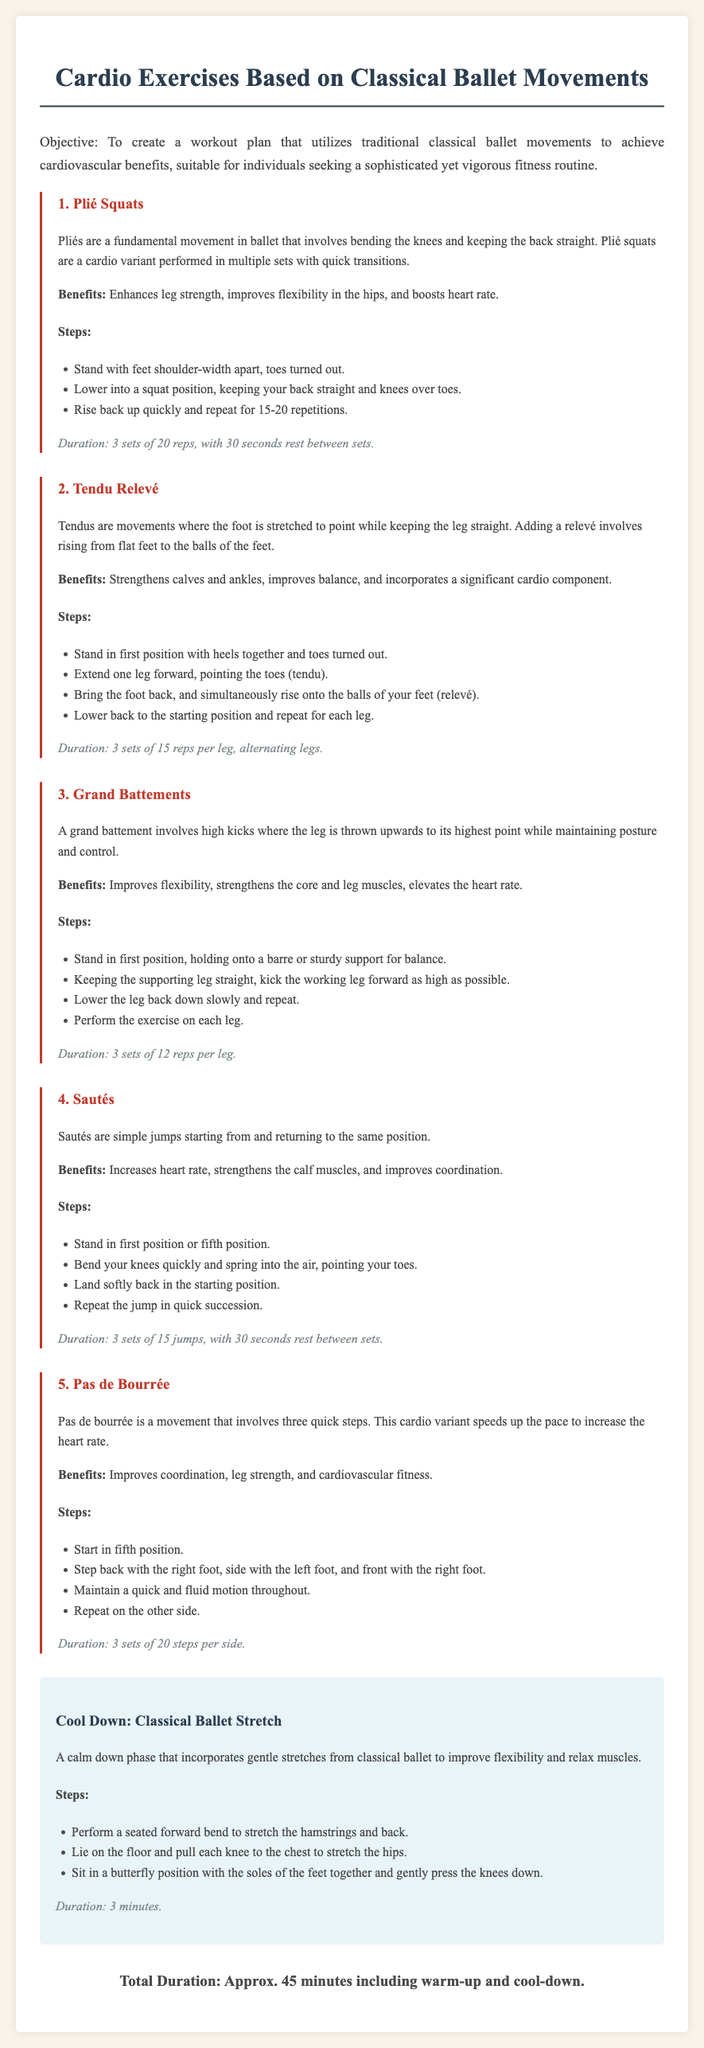What is the objective of the workout plan? The objective is to create a workout plan that utilizes traditional classical ballet movements to achieve cardiovascular benefits, suitable for individuals seeking a sophisticated yet vigorous fitness routine.
Answer: To create a workout plan that utilizes traditional classical ballet movements to achieve cardiovascular benefits How many sets are recommended for Plié Squats? The document specifies that Plié Squats should be performed in 3 sets with a certain number of repetitions.
Answer: 3 sets What is the duration for Tendu Relevé? The document states the duration for Tendu Relevé, which includes sets and repetitions.
Answer: 3 sets of 15 reps per leg What is one benefit of Grand Battements? The benefits of Grand Battements are mentioned, highlighting improvement in particular areas.
Answer: Improves flexibility How long should the cool down last? The document indicates how long the cool down phase should take.
Answer: 3 minutes What are Sautés? The document describes Sautés in terms of their nature as a cardio exercise.
Answer: Simple jumps What exercise involves three quick steps? The document identifies an exercise characterized by this movement pattern.
Answer: Pas de Bourrée What is the total duration of the workout, including warm-up and cool-down? The total duration is mentioned in the document as inclusive of warm-up and cool-down times.
Answer: Approx. 45 minutes What position should you start in for Tendu Relevé? The starting position for Tendu Relevé is specified in the steps provided in the exercise description.
Answer: First position Which exercise helps to improve coordination? The document lists several exercises and specifies which one focuses on this particular benefit.
Answer: Pas de Bourrée 